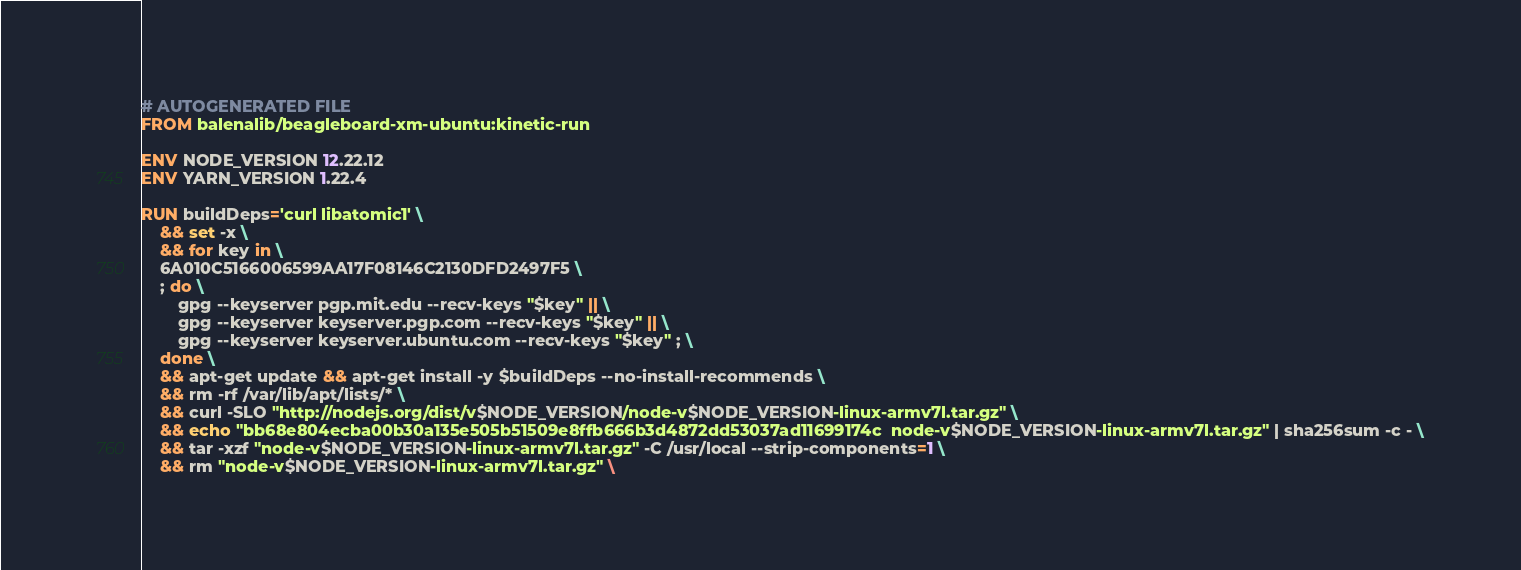<code> <loc_0><loc_0><loc_500><loc_500><_Dockerfile_># AUTOGENERATED FILE
FROM balenalib/beagleboard-xm-ubuntu:kinetic-run

ENV NODE_VERSION 12.22.12
ENV YARN_VERSION 1.22.4

RUN buildDeps='curl libatomic1' \
	&& set -x \
	&& for key in \
	6A010C5166006599AA17F08146C2130DFD2497F5 \
	; do \
		gpg --keyserver pgp.mit.edu --recv-keys "$key" || \
		gpg --keyserver keyserver.pgp.com --recv-keys "$key" || \
		gpg --keyserver keyserver.ubuntu.com --recv-keys "$key" ; \
	done \
	&& apt-get update && apt-get install -y $buildDeps --no-install-recommends \
	&& rm -rf /var/lib/apt/lists/* \
	&& curl -SLO "http://nodejs.org/dist/v$NODE_VERSION/node-v$NODE_VERSION-linux-armv7l.tar.gz" \
	&& echo "bb68e804ecba00b30a135e505b51509e8ffb666b3d4872dd53037ad11699174c  node-v$NODE_VERSION-linux-armv7l.tar.gz" | sha256sum -c - \
	&& tar -xzf "node-v$NODE_VERSION-linux-armv7l.tar.gz" -C /usr/local --strip-components=1 \
	&& rm "node-v$NODE_VERSION-linux-armv7l.tar.gz" \</code> 